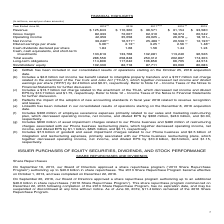According to Microsoft Corporation's financial document, Why did net income in 2018 decrease from that in 2017? Includes a $13.7 billion net charge related to the enactment of the TCJA, which decreased net income and diluted EPS by $13.7 billion and $1.75, respectively.. The document states: "(c) Includes a $13.7 billion net charge related to the enactment of the TCJA, which decreased net income and diluted EPS by $13.7 billion and $1.75, r..." Also, can you calculate: How much would operating income in 2015 have been if there were no goodwill and impairment charges in 2015? Based on the calculation: 10.0 billion + 18,161 million , the result is 28161 (in millions). This is based on the information: "rating income 42,959 35,058 29,025 (f) 26,078 (g) 18,161 (h) operating income, net income, and diluted EPS by $10.0 billion, $9.5 billion, and $1.15, respectively...." The key data points involved are: 10.0, 18,161. Also, When was Linkedin acquired? According to the financial document, December 8, 2016. The relevant text states: "onsolidated results of operations starting on the December 8, 2016 acquisition date...." Also, When was GitHub acquired? According to the financial document, October 25, 2018. The relevant text states: "onsolidated results of operations starting on the October 25, 2018 acquisition date ...." Also, can you calculate: What was the total liabilities in 2018? Based on the calculation: 258,848-82,718, the result is 176130 (in millions). This is based on the information: "Stockholders’ equity 102,330 82,718 87,711 83,090 80,083 Total assets 286,556 258,848 250,312 202,897 174,303..." The key data points involved are: 258,848, 82,718. Also, can you calculate: What was the average revenue over the 3 year period from 2017 to 2019? To answer this question, I need to perform calculations using the financial data. The calculation is: (125,843+110,360+96,571)/(2019-2017+1), which equals 110924.67 (in millions). This is based on the information: "Revenue $ 125,843 $ 110,360 $ 96,571 $ 91,154 $ 93,580 Revenue $ 125,843 $ 110,360 $ 96,571 $ 91,154 $ 93,580 Revenue $ 125,843 $ 110,360 $ 96,571 $ 91,154 $ 93,580..." The key data points involved are: 110,360, 125,843, 96,571. 